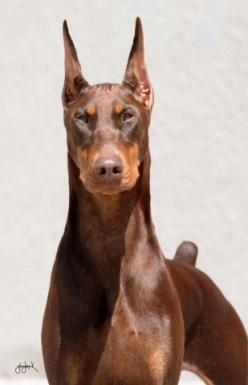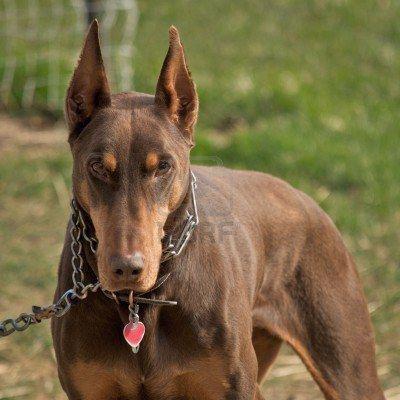The first image is the image on the left, the second image is the image on the right. Examine the images to the left and right. Is the description "The right image contains exactly two dogs." accurate? Answer yes or no. No. The first image is the image on the left, the second image is the image on the right. Given the left and right images, does the statement "One image includes a non-standing doberman wearing a chain collar, and the other image shows at least two dogs standing side-by-side on the grass." hold true? Answer yes or no. No. 